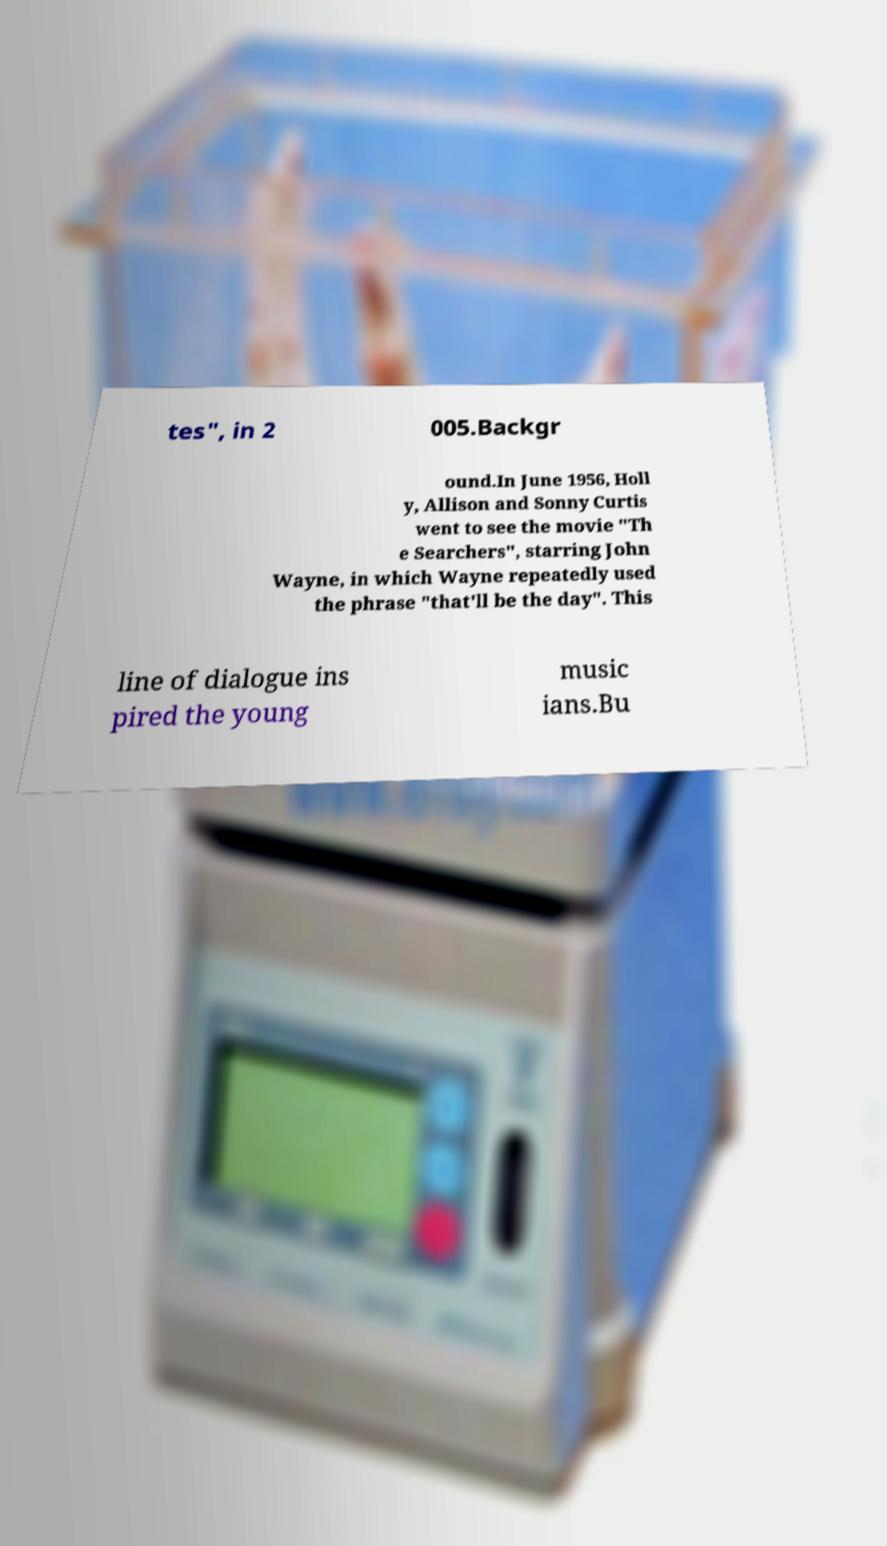Could you assist in decoding the text presented in this image and type it out clearly? tes", in 2 005.Backgr ound.In June 1956, Holl y, Allison and Sonny Curtis went to see the movie "Th e Searchers", starring John Wayne, in which Wayne repeatedly used the phrase "that'll be the day". This line of dialogue ins pired the young music ians.Bu 